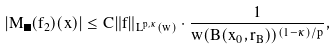<formula> <loc_0><loc_0><loc_500><loc_500>\left | M _ { \Omega } ( f _ { 2 } ) ( x ) \right | \leq C \| f \| _ { L ^ { p , \kappa } ( w ) } \cdot \frac { 1 } { w ( B ( x _ { 0 } , r _ { B } ) ) ^ { ( 1 - \kappa ) / p } } ,</formula> 